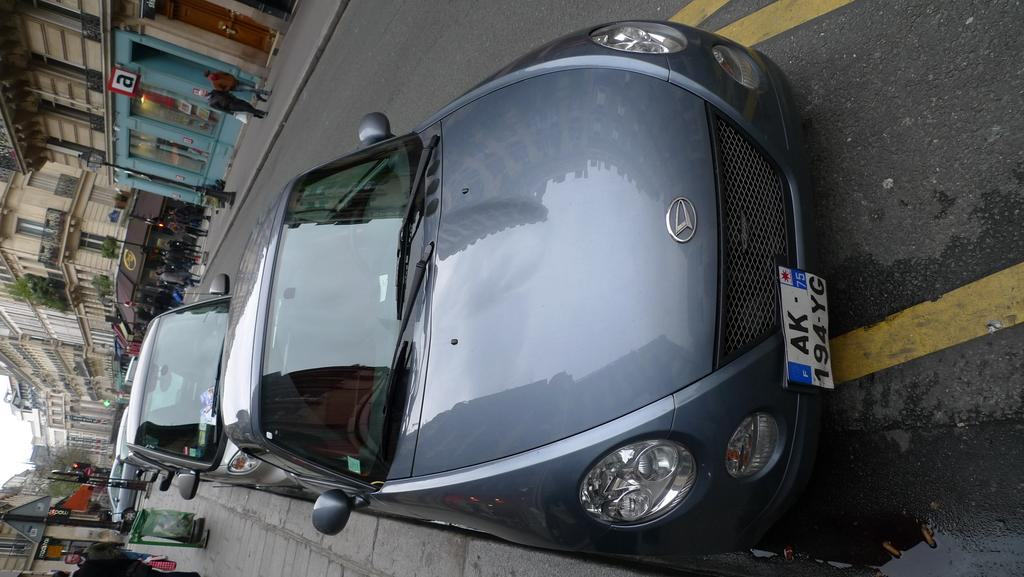<image>
Give a short and clear explanation of the subsequent image. A grey car that is parked on the side of the street, the license plate says AK 194YG. 